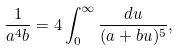Convert formula to latex. <formula><loc_0><loc_0><loc_500><loc_500>\frac { 1 } { a ^ { 4 } b } = 4 \int _ { 0 } ^ { \infty } \frac { d u } { ( a + b u ) ^ { 5 } } ,</formula> 